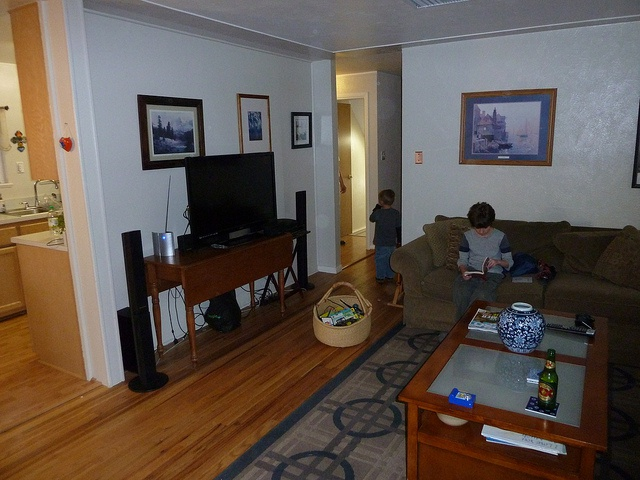Describe the objects in this image and their specific colors. I can see couch in gray and black tones, tv in gray and black tones, people in gray, black, maroon, and darkblue tones, vase in gray, black, and navy tones, and people in gray, black, and navy tones in this image. 